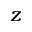<formula> <loc_0><loc_0><loc_500><loc_500>z</formula> 